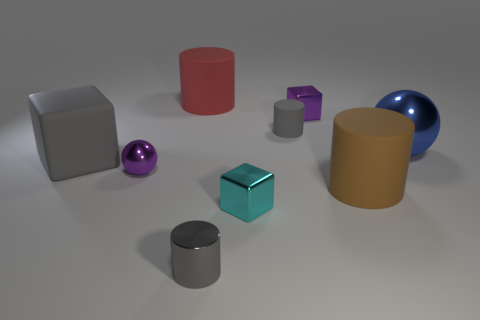Subtract all rubber cylinders. How many cylinders are left? 1 Add 1 tiny yellow matte cylinders. How many objects exist? 10 Subtract all brown cylinders. How many cylinders are left? 3 Subtract all green cubes. How many gray cylinders are left? 2 Subtract 2 cylinders. How many cylinders are left? 2 Subtract all gray cylinders. Subtract all green spheres. How many cylinders are left? 2 Subtract all large brown cylinders. Subtract all purple blocks. How many objects are left? 7 Add 3 purple cubes. How many purple cubes are left? 4 Add 7 tiny red metal cylinders. How many tiny red metal cylinders exist? 7 Subtract 0 green spheres. How many objects are left? 9 